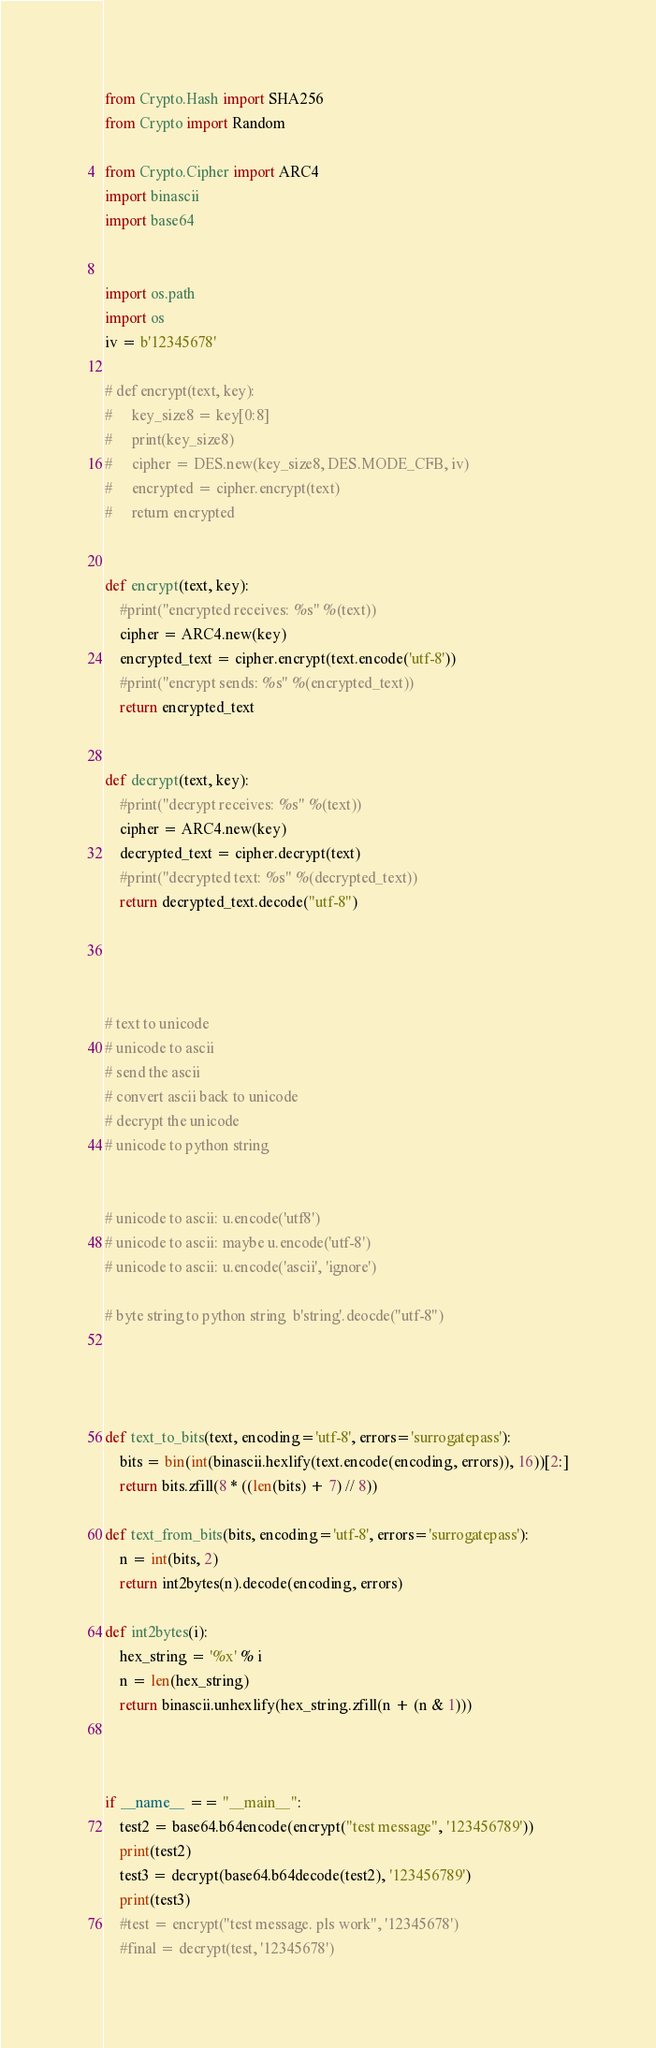Convert code to text. <code><loc_0><loc_0><loc_500><loc_500><_Python_>from Crypto.Hash import SHA256
from Crypto import Random

from Crypto.Cipher import ARC4
import binascii
import base64


import os.path
import os
iv = b'12345678'

# def encrypt(text, key):
#     key_size8 = key[0:8]
#     print(key_size8)
#     cipher = DES.new(key_size8, DES.MODE_CFB, iv)
#     encrypted = cipher.encrypt(text)
#     return encrypted


def encrypt(text, key):
    #print("encrypted receives: %s" %(text))
    cipher = ARC4.new(key)
    encrypted_text = cipher.encrypt(text.encode('utf-8'))
    #print("encrypt sends: %s" %(encrypted_text))
    return encrypted_text


def decrypt(text, key):
    #print("decrypt receives: %s" %(text))
    cipher = ARC4.new(key)
    decrypted_text = cipher.decrypt(text)
    #print("decrypted text: %s" %(decrypted_text))
    return decrypted_text.decode("utf-8")




# text to unicode
# unicode to ascii
# send the ascii
# convert ascii back to unicode
# decrypt the unicode
# unicode to python string


# unicode to ascii: u.encode('utf8')
# unicode to ascii: maybe u.encode('utf-8')
# unicode to ascii: u.encode('ascii', 'ignore')

# byte string to python string  b'string'.deocde("utf-8")




def text_to_bits(text, encoding='utf-8', errors='surrogatepass'):
    bits = bin(int(binascii.hexlify(text.encode(encoding, errors)), 16))[2:]
    return bits.zfill(8 * ((len(bits) + 7) // 8))

def text_from_bits(bits, encoding='utf-8', errors='surrogatepass'):
    n = int(bits, 2)
    return int2bytes(n).decode(encoding, errors)

def int2bytes(i):
    hex_string = '%x' % i
    n = len(hex_string)
    return binascii.unhexlify(hex_string.zfill(n + (n & 1)))



if __name__ == "__main__":
    test2 = base64.b64encode(encrypt("test message", '123456789'))
    print(test2)
    test3 = decrypt(base64.b64decode(test2), '123456789')
    print(test3)
    #test = encrypt("test message. pls work", '12345678')
    #final = decrypt(test, '12345678')


</code> 